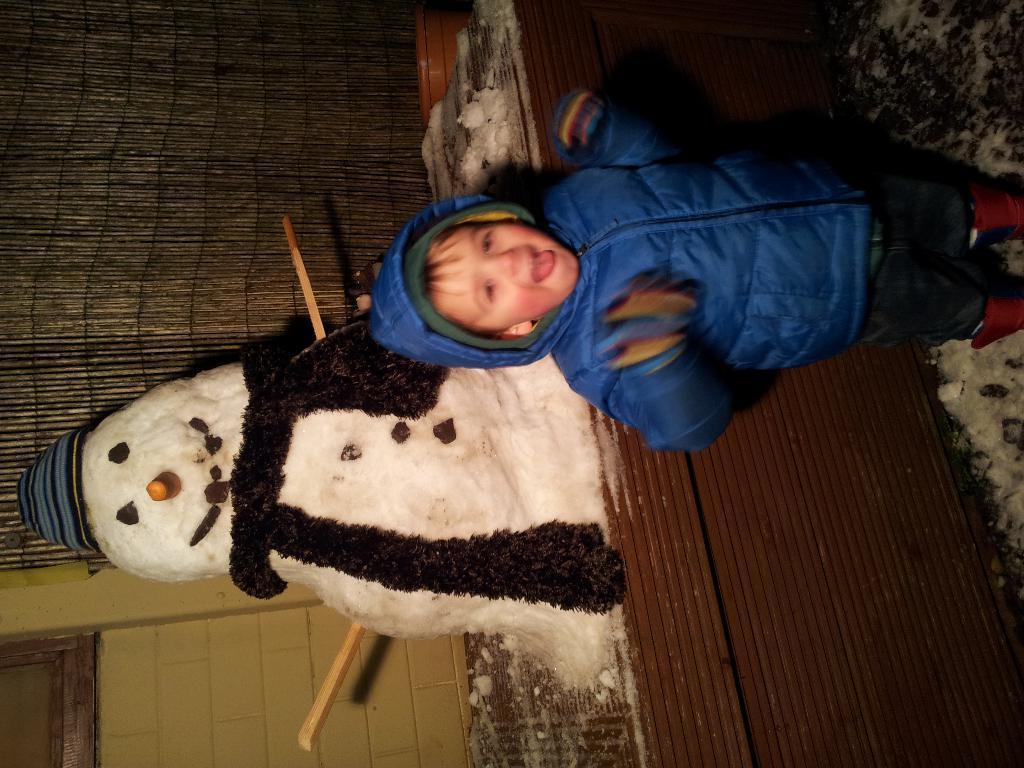Describe this image in one or two sentences. In the foreground of this picture, there is a boy standing and behind him there is a snowman, wall, and a curtain. 